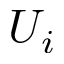<formula> <loc_0><loc_0><loc_500><loc_500>U _ { i }</formula> 